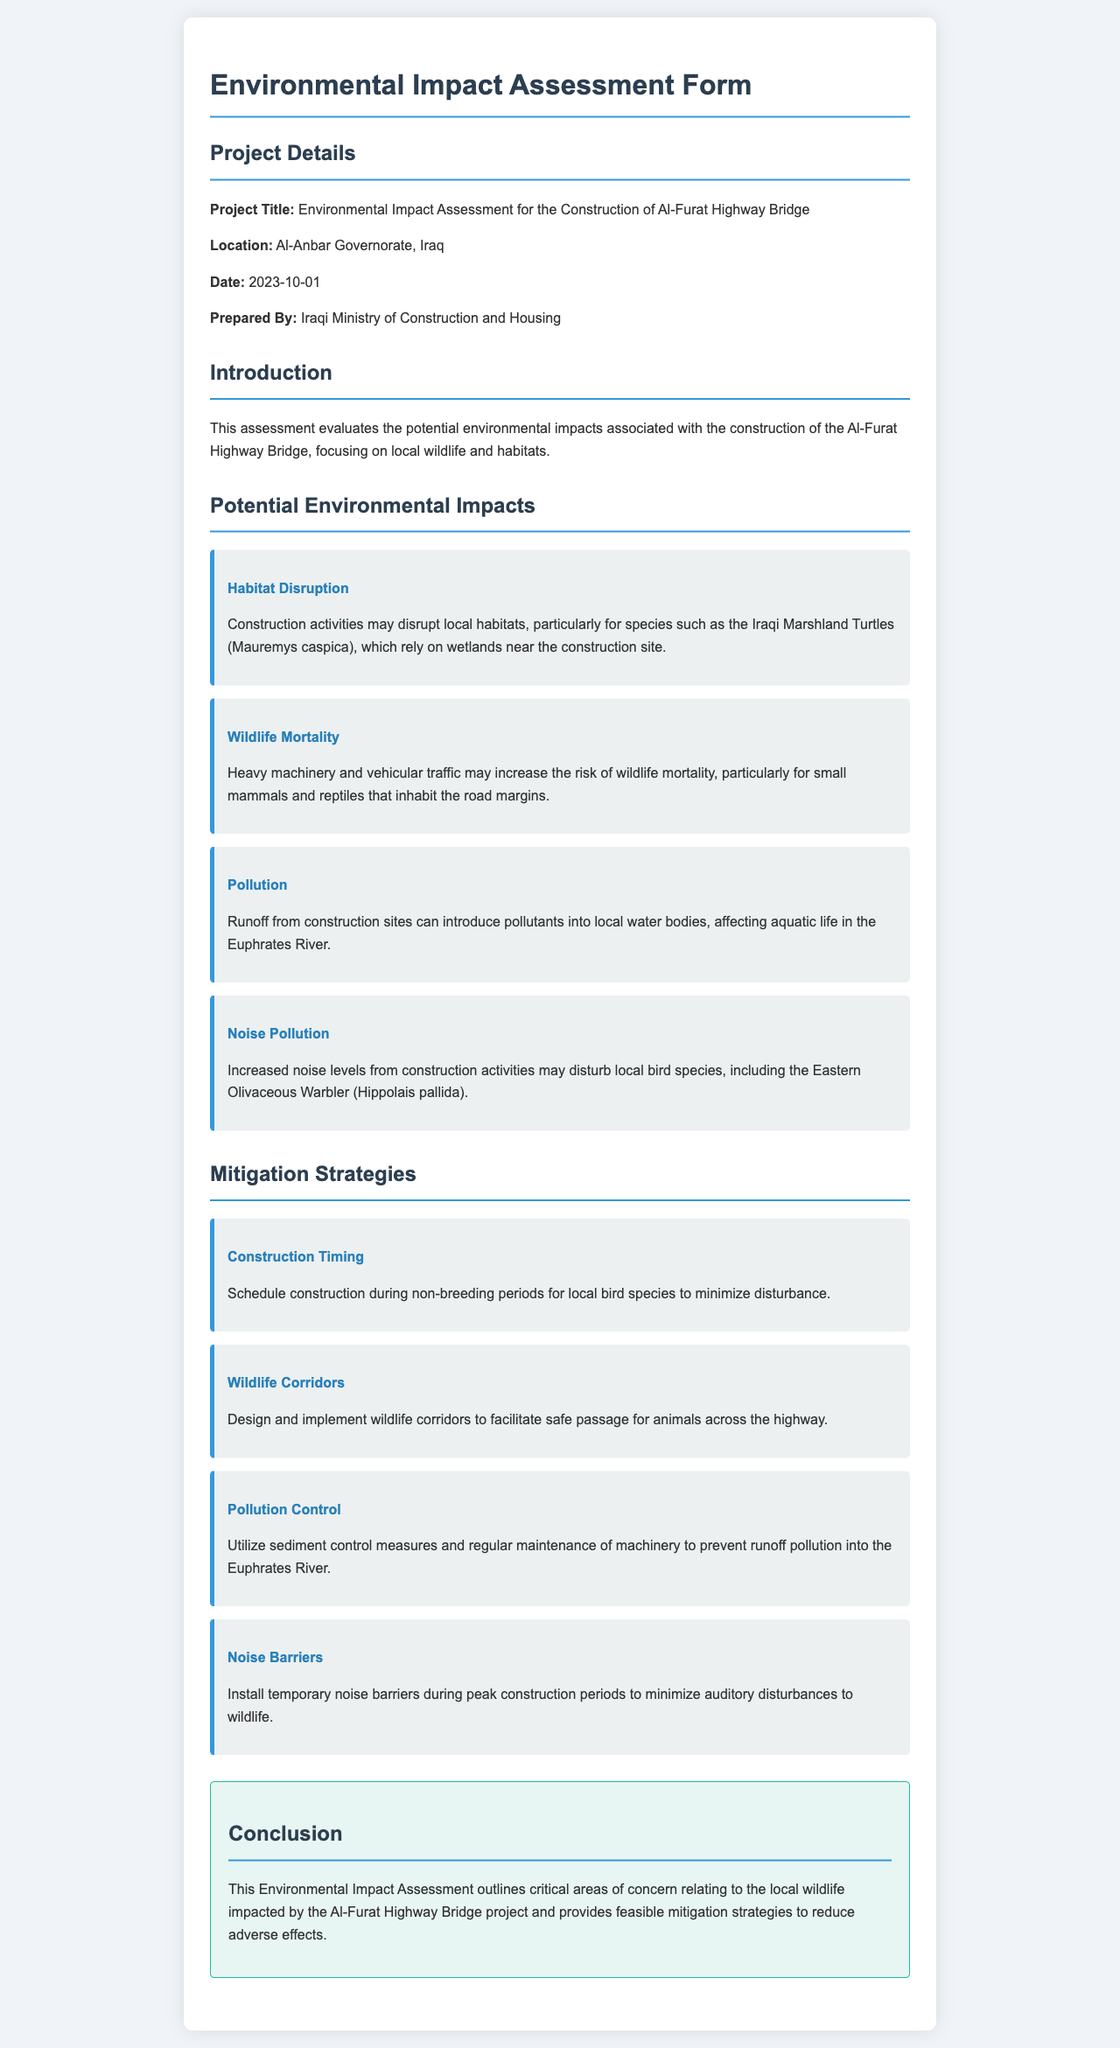what is the project title? The project title is mentioned at the beginning of the document in the Project Details section.
Answer: Environmental Impact Assessment for the Construction of Al-Furat Highway Bridge where is the construction site located? The location of the project is specified in the Project Details section.
Answer: Al-Anbar Governorate, Iraq who prepared the assessment? The document specifies who prepared the assessment in the Project Details section.
Answer: Iraqi Ministry of Construction and Housing which species may experience habitat disruption? The species affected by habitat disruption is mentioned in the Potential Environmental Impacts section.
Answer: Iraqi Marshland Turtles what type of pollution is a concern related to the construction? The type of pollution that could impact local water bodies is identified in the Potential Environmental Impacts section.
Answer: Runoff pollution what is one proposed mitigation strategy? The document outlines several strategies; one can be found in the Mitigation Strategies section.
Answer: Construction Timing how do noise barriers help in the project? The role of noise barriers is described in the Mitigation Strategies section regarding their effect on wildlife.
Answer: Minimize auditory disturbances which river is mentioned as being impacted by pollution? The specific water body affected by pollution is stated in the Potential Environmental Impacts section.
Answer: Euphrates River what date was the assessment prepared? The date the assessment was prepared is mentioned in the Project Details section.
Answer: 2023-10-01 